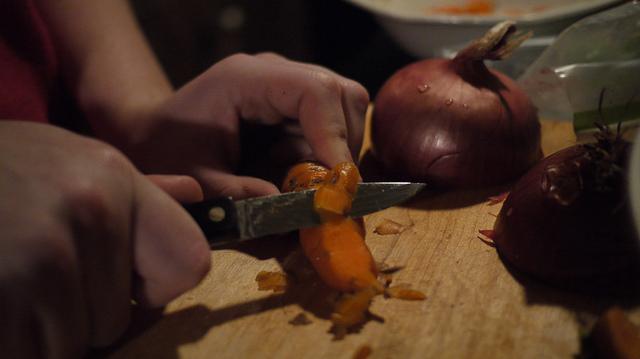Is the carrot totally peeled?
Short answer required. No. Is this a root vegetable?
Keep it brief. Yes. Is the sharp side of the knife up or down?
Concise answer only. Down. 